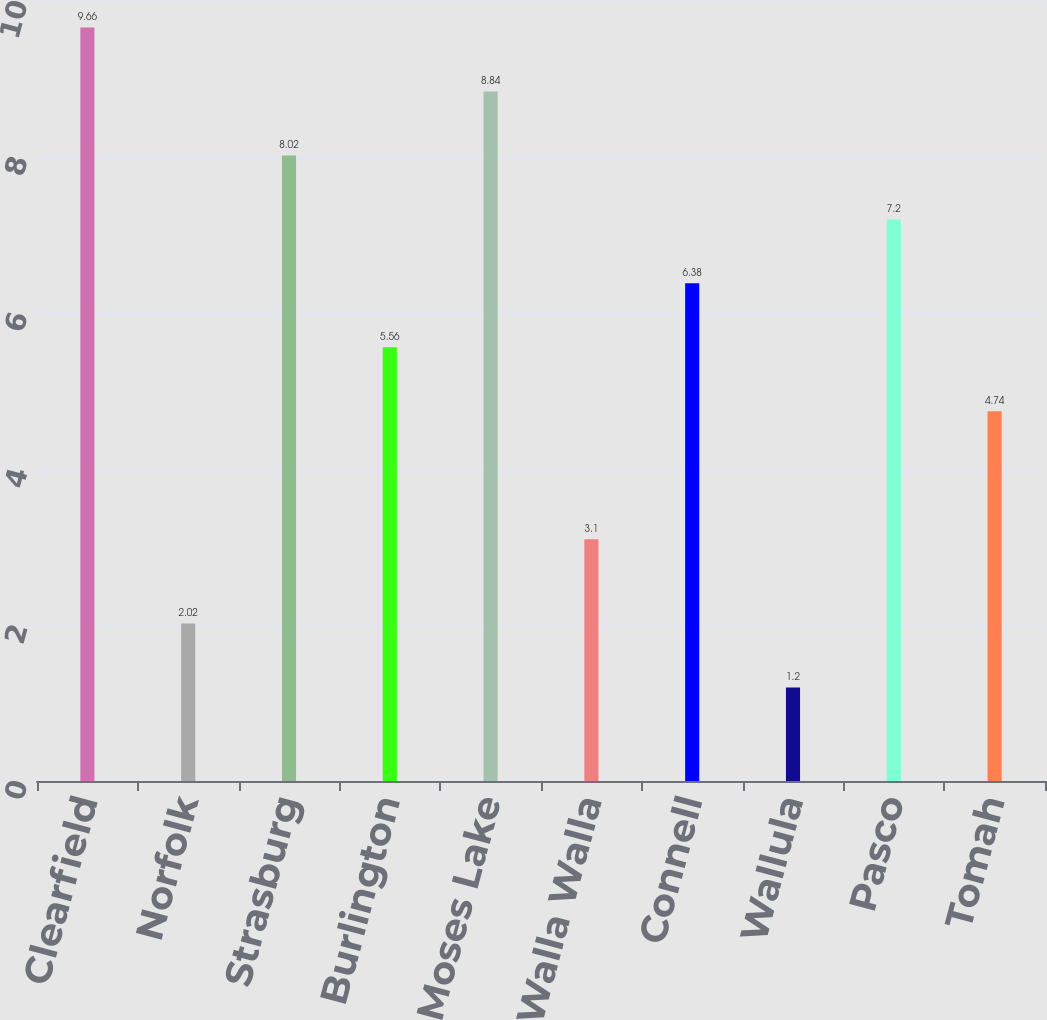Convert chart to OTSL. <chart><loc_0><loc_0><loc_500><loc_500><bar_chart><fcel>Clearfield<fcel>Norfolk<fcel>Strasburg<fcel>Burlington<fcel>Moses Lake<fcel>Walla Walla<fcel>Connell<fcel>Wallula<fcel>Pasco<fcel>Tomah<nl><fcel>9.66<fcel>2.02<fcel>8.02<fcel>5.56<fcel>8.84<fcel>3.1<fcel>6.38<fcel>1.2<fcel>7.2<fcel>4.74<nl></chart> 